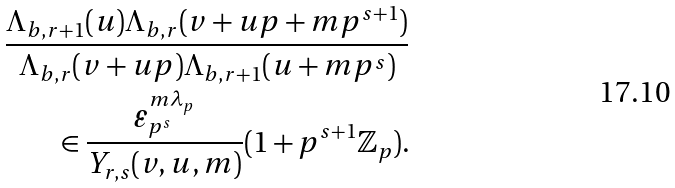<formula> <loc_0><loc_0><loc_500><loc_500>\frac { \Lambda _ { b , r + 1 } ( u ) \Lambda _ { b , r } ( v + u p + m p ^ { s + 1 } ) } { \Lambda _ { b , r } ( v + u p ) \Lambda _ { b , r + 1 } ( u + m p ^ { s } ) } \\ \in \frac { \varepsilon _ { p ^ { s } } ^ { m \lambda _ { p } } } { Y _ { r , s } ( v , u , m ) } ( 1 + p ^ { s + 1 } \mathbb { Z } _ { p } ) .</formula> 